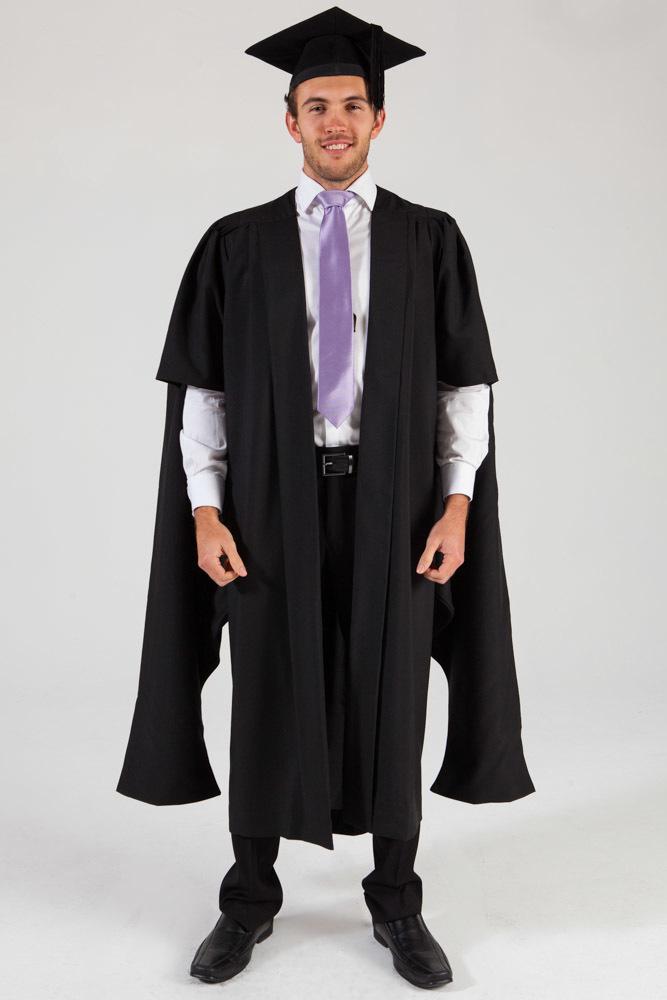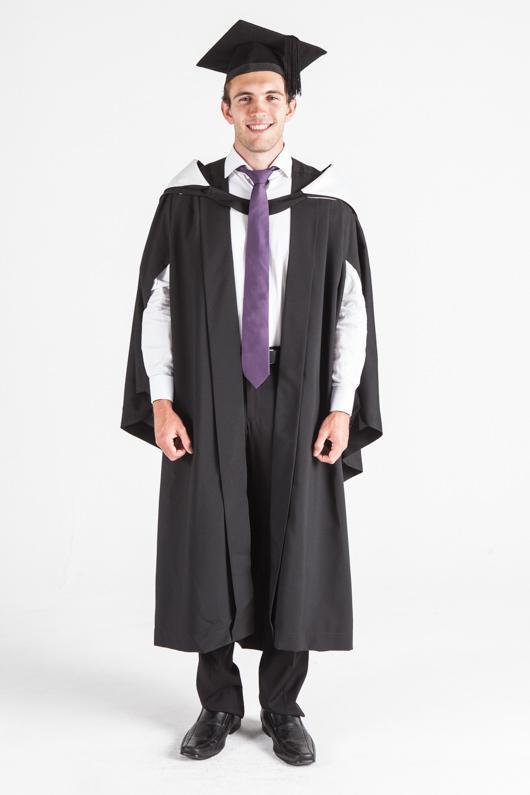The first image is the image on the left, the second image is the image on the right. For the images shown, is this caption "An image shows a male graduate wearing something yellow around his neck." true? Answer yes or no. No. The first image is the image on the left, the second image is the image on the right. Examine the images to the left and right. Is the description "In both images a man wearing a black cap and gown and purple tie is standing facing forward with his arms at his sides." accurate? Answer yes or no. Yes. 